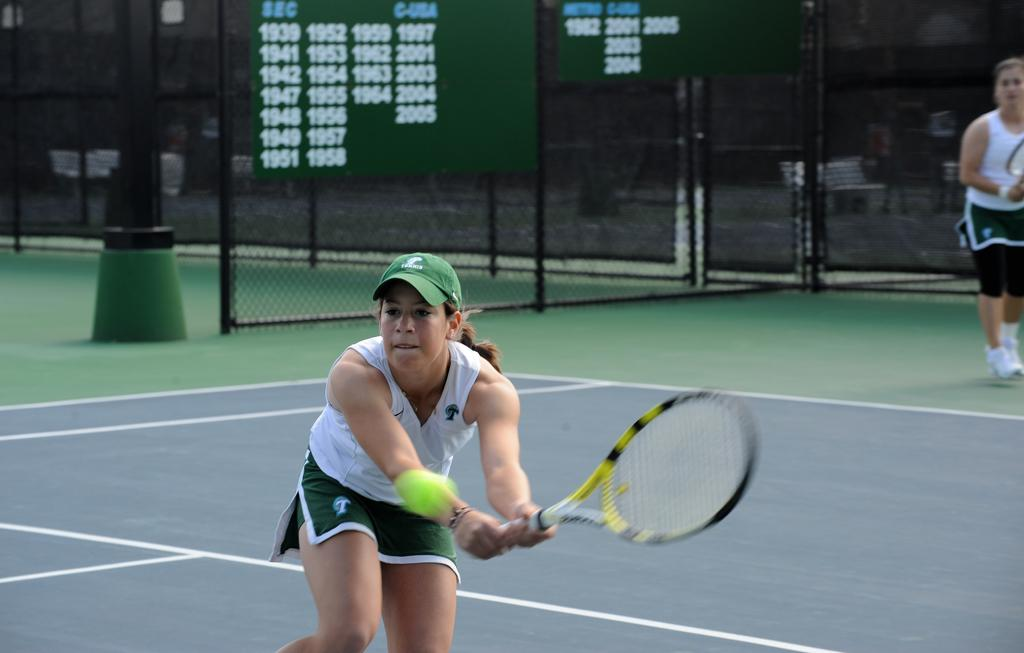Who is the main subject in the image? There is a girl in the image. What activity is the girl engaged in? The girl is playing tennis. What type of disgust can be seen on the girl's face while playing tennis in the image? There is no indication of disgust on the girl's face in the image; she appears to be focused on playing tennis. 